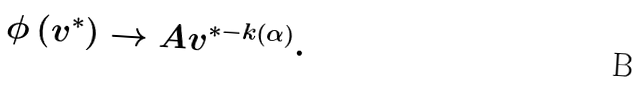Convert formula to latex. <formula><loc_0><loc_0><loc_500><loc_500>\phi \left ( v ^ { \ast } \right ) \rightarrow A v ^ { \ast - k \left ( \alpha \right ) } .</formula> 